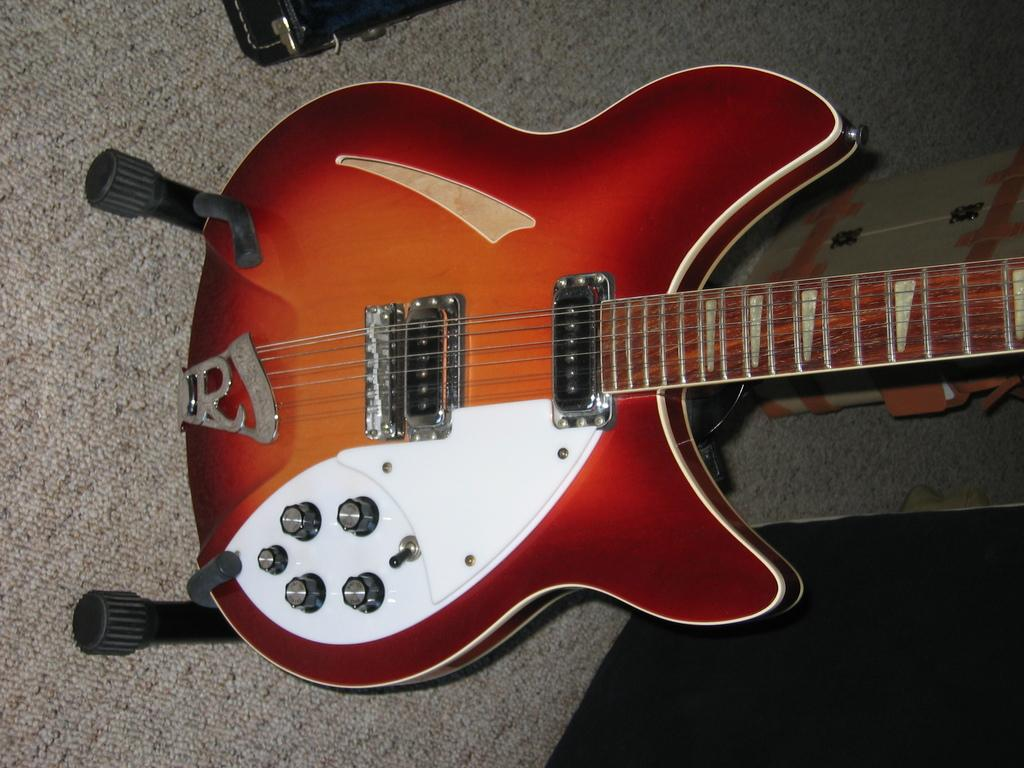What musical instrument is present in the picture? There is a guitar in the picture. How is the guitar positioned in the image? The guitar is placed on stands. What are the essential components of the guitar? The guitar has strings and tuners. What is the color of the guitar in the image? The guitar is red in color. What type of shoes is the guitar wearing in the image? The guitar is not a living being and does not wear shoes; it is an inanimate object. 